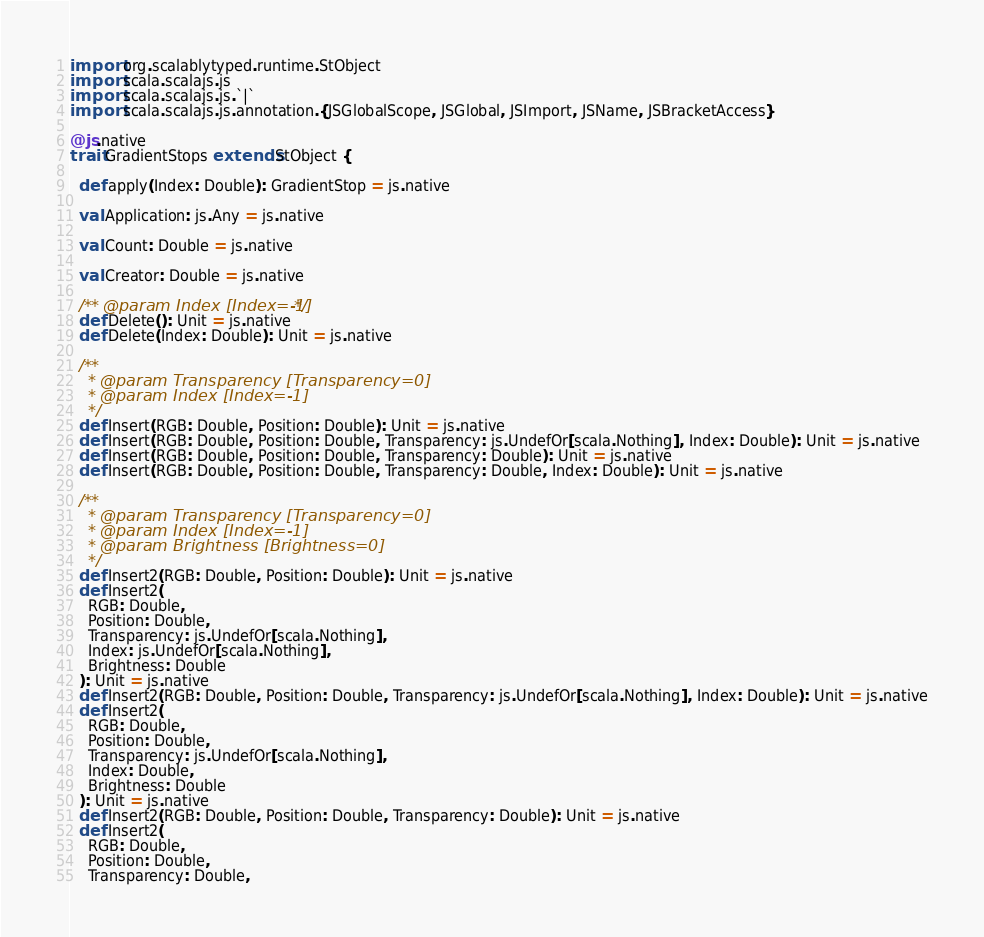Convert code to text. <code><loc_0><loc_0><loc_500><loc_500><_Scala_>import org.scalablytyped.runtime.StObject
import scala.scalajs.js
import scala.scalajs.js.`|`
import scala.scalajs.js.annotation.{JSGlobalScope, JSGlobal, JSImport, JSName, JSBracketAccess}

@js.native
trait GradientStops extends StObject {
  
  def apply(Index: Double): GradientStop = js.native
  
  val Application: js.Any = js.native
  
  val Count: Double = js.native
  
  val Creator: Double = js.native
  
  /** @param Index [Index=-1] */
  def Delete(): Unit = js.native
  def Delete(Index: Double): Unit = js.native
  
  /**
    * @param Transparency [Transparency=0]
    * @param Index [Index=-1]
    */
  def Insert(RGB: Double, Position: Double): Unit = js.native
  def Insert(RGB: Double, Position: Double, Transparency: js.UndefOr[scala.Nothing], Index: Double): Unit = js.native
  def Insert(RGB: Double, Position: Double, Transparency: Double): Unit = js.native
  def Insert(RGB: Double, Position: Double, Transparency: Double, Index: Double): Unit = js.native
  
  /**
    * @param Transparency [Transparency=0]
    * @param Index [Index=-1]
    * @param Brightness [Brightness=0]
    */
  def Insert2(RGB: Double, Position: Double): Unit = js.native
  def Insert2(
    RGB: Double,
    Position: Double,
    Transparency: js.UndefOr[scala.Nothing],
    Index: js.UndefOr[scala.Nothing],
    Brightness: Double
  ): Unit = js.native
  def Insert2(RGB: Double, Position: Double, Transparency: js.UndefOr[scala.Nothing], Index: Double): Unit = js.native
  def Insert2(
    RGB: Double,
    Position: Double,
    Transparency: js.UndefOr[scala.Nothing],
    Index: Double,
    Brightness: Double
  ): Unit = js.native
  def Insert2(RGB: Double, Position: Double, Transparency: Double): Unit = js.native
  def Insert2(
    RGB: Double,
    Position: Double,
    Transparency: Double,</code> 